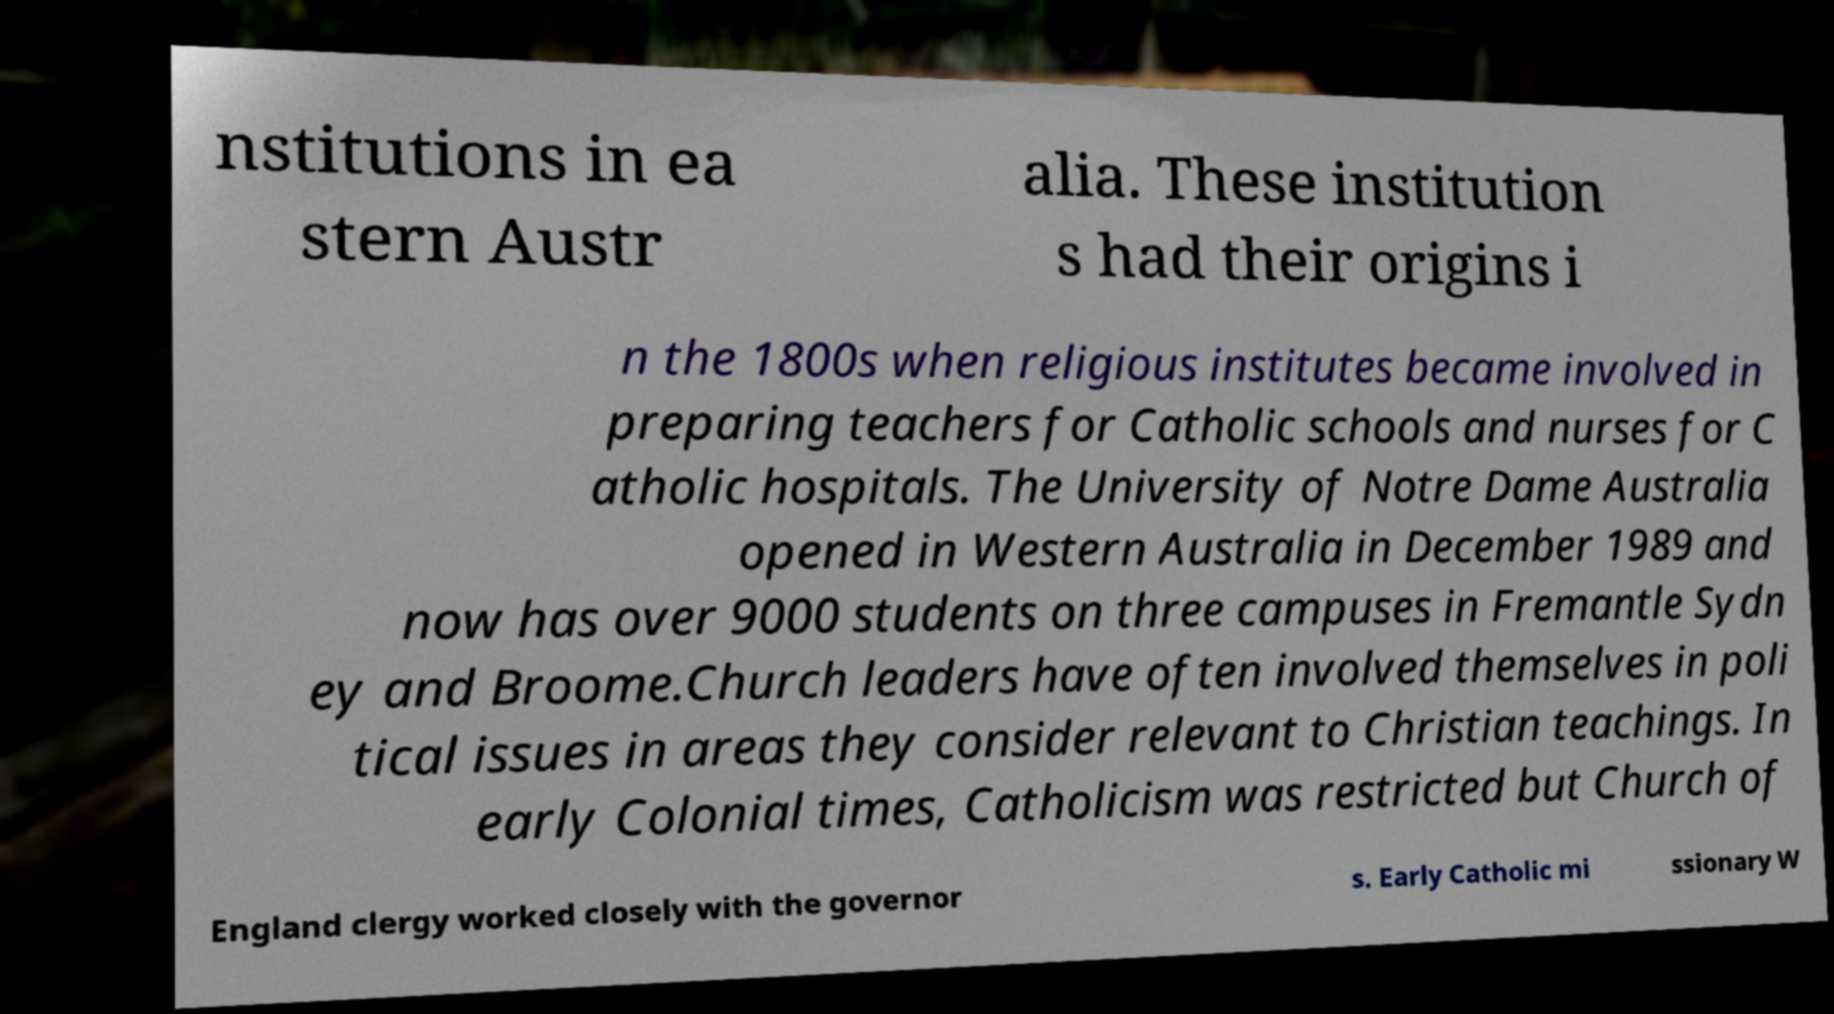Could you assist in decoding the text presented in this image and type it out clearly? nstitutions in ea stern Austr alia. These institution s had their origins i n the 1800s when religious institutes became involved in preparing teachers for Catholic schools and nurses for C atholic hospitals. The University of Notre Dame Australia opened in Western Australia in December 1989 and now has over 9000 students on three campuses in Fremantle Sydn ey and Broome.Church leaders have often involved themselves in poli tical issues in areas they consider relevant to Christian teachings. In early Colonial times, Catholicism was restricted but Church of England clergy worked closely with the governor s. Early Catholic mi ssionary W 